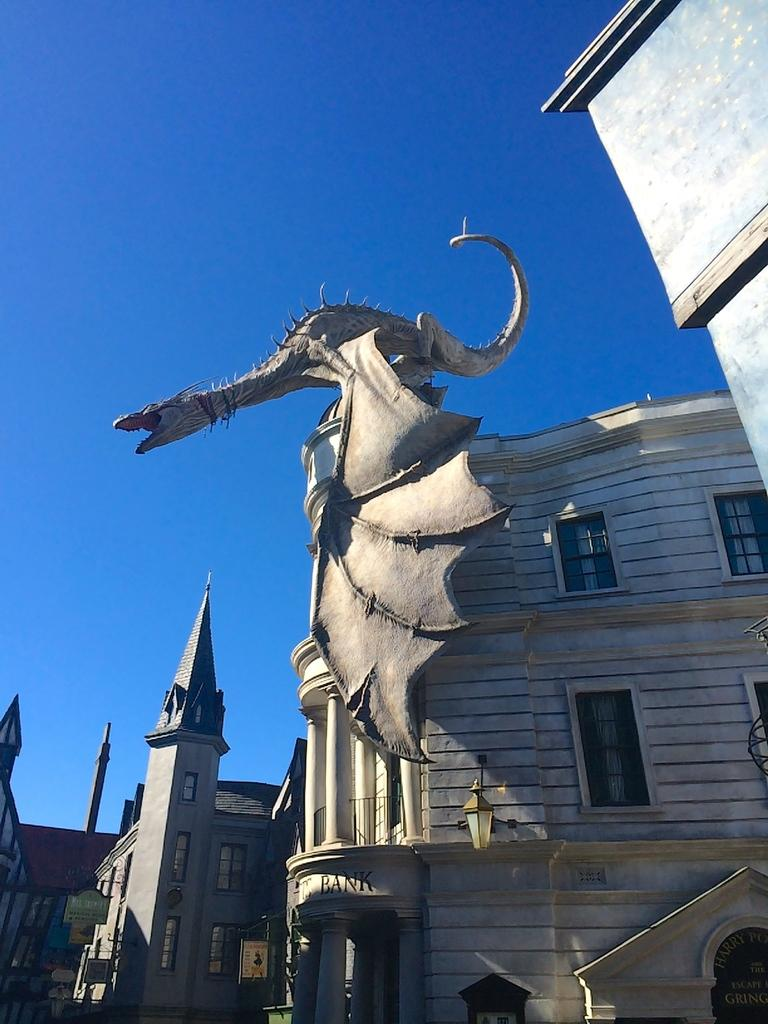What type of structures are present in the image? There are buildings with windows in the image. What is attached to the buildings? There are boards on the buildings. What additional feature can be seen in the image? There is a statue in the image. What can be seen in the background of the image? The sky is visible in the background of the image. Can you tell me how many volcanoes are visible in the image? There are no volcanoes present in the image. What type of nose can be seen on the statue in the image? There is no statue with a nose in the image; the statue does not have any facial features. 